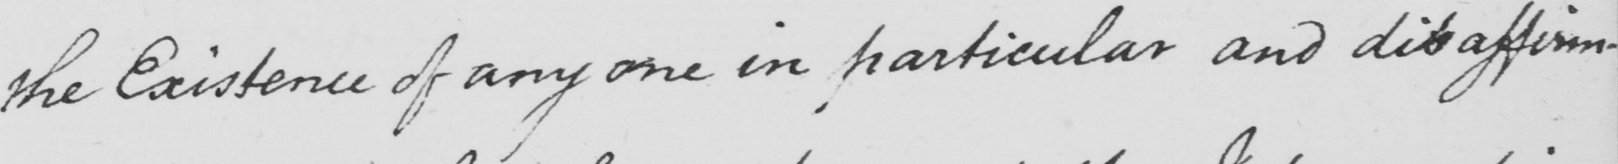Please transcribe the handwritten text in this image. the Existence of any one in particular and disaffirming 